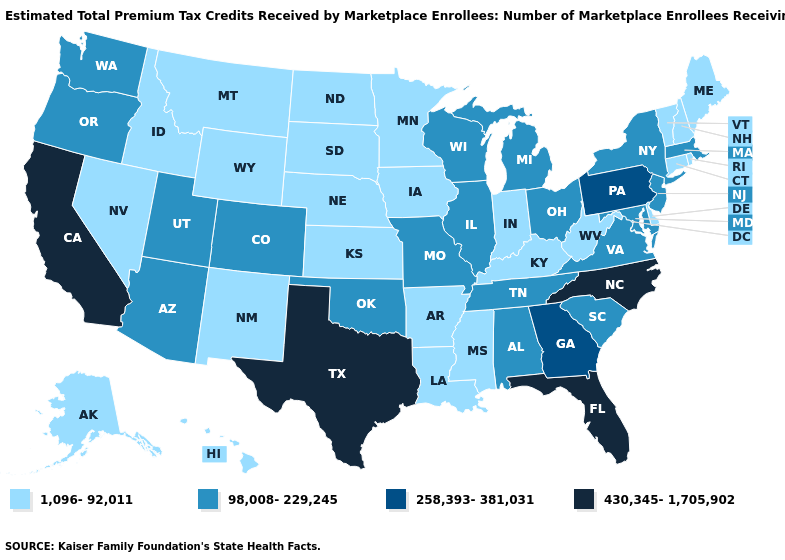Does New York have the highest value in the Northeast?
Be succinct. No. Name the states that have a value in the range 430,345-1,705,902?
Be succinct. California, Florida, North Carolina, Texas. Name the states that have a value in the range 430,345-1,705,902?
Give a very brief answer. California, Florida, North Carolina, Texas. Does the first symbol in the legend represent the smallest category?
Answer briefly. Yes. Among the states that border Tennessee , which have the highest value?
Give a very brief answer. North Carolina. Does California have the lowest value in the USA?
Quick response, please. No. Is the legend a continuous bar?
Short answer required. No. Does the first symbol in the legend represent the smallest category?
Give a very brief answer. Yes. Does the first symbol in the legend represent the smallest category?
Answer briefly. Yes. What is the value of Delaware?
Give a very brief answer. 1,096-92,011. Name the states that have a value in the range 98,008-229,245?
Write a very short answer. Alabama, Arizona, Colorado, Illinois, Maryland, Massachusetts, Michigan, Missouri, New Jersey, New York, Ohio, Oklahoma, Oregon, South Carolina, Tennessee, Utah, Virginia, Washington, Wisconsin. How many symbols are there in the legend?
Quick response, please. 4. Name the states that have a value in the range 1,096-92,011?
Concise answer only. Alaska, Arkansas, Connecticut, Delaware, Hawaii, Idaho, Indiana, Iowa, Kansas, Kentucky, Louisiana, Maine, Minnesota, Mississippi, Montana, Nebraska, Nevada, New Hampshire, New Mexico, North Dakota, Rhode Island, South Dakota, Vermont, West Virginia, Wyoming. What is the value of Pennsylvania?
Short answer required. 258,393-381,031. Which states hav the highest value in the South?
Short answer required. Florida, North Carolina, Texas. 